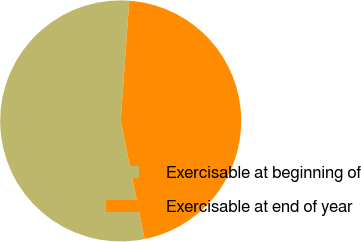Convert chart. <chart><loc_0><loc_0><loc_500><loc_500><pie_chart><fcel>Exercisable at beginning of<fcel>Exercisable at end of year<nl><fcel>54.31%<fcel>45.69%<nl></chart> 